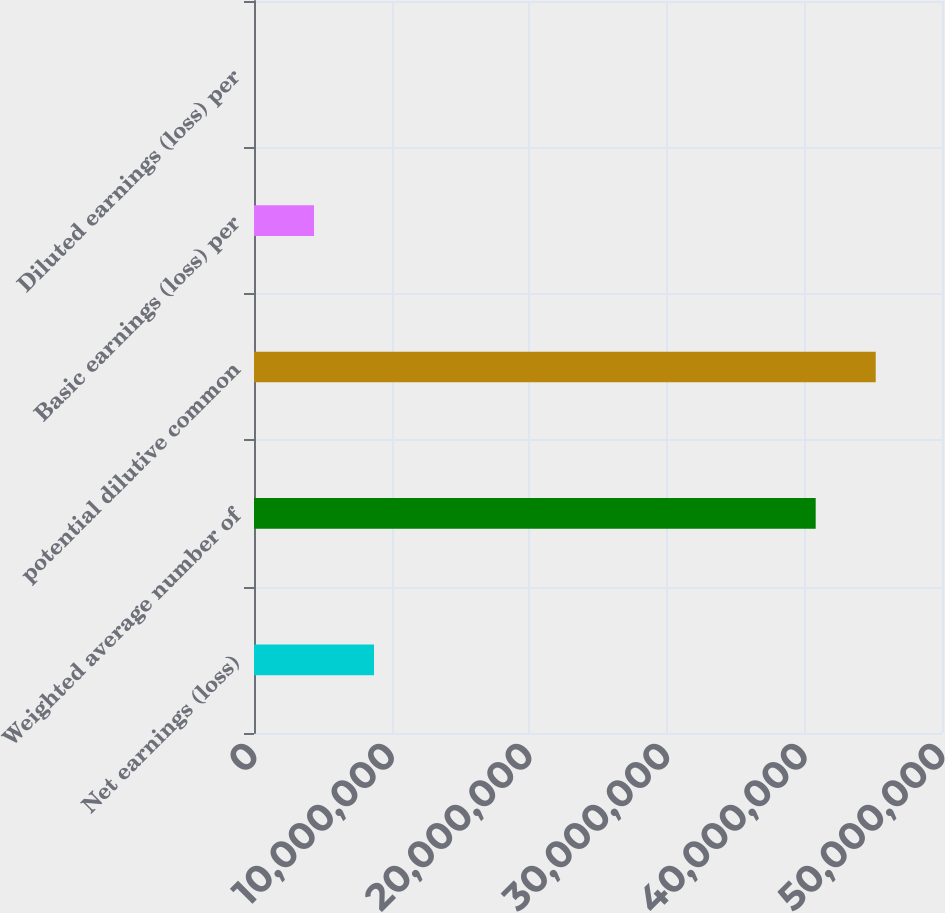<chart> <loc_0><loc_0><loc_500><loc_500><bar_chart><fcel>Net earnings (loss)<fcel>Weighted average number of<fcel>potential dilutive common<fcel>Basic earnings (loss) per<fcel>Diluted earnings (loss) per<nl><fcel>8.72329e+06<fcel>4.08209e+07<fcel>4.51826e+07<fcel>4.36165e+06<fcel>1.02<nl></chart> 